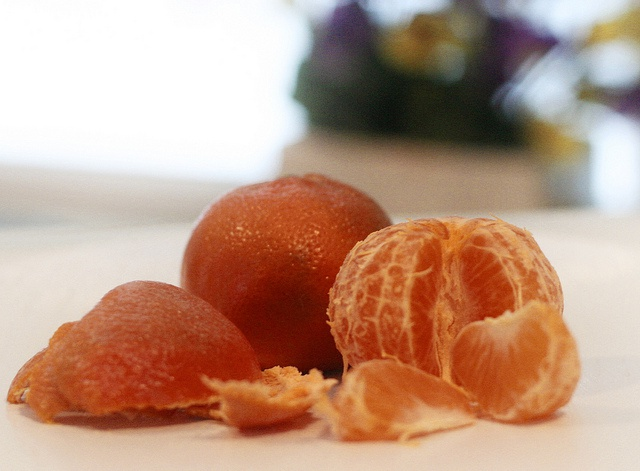Describe the objects in this image and their specific colors. I can see orange in white, red, tan, and brown tones, orange in white, brown, salmon, and tan tones, and orange in white, maroon, brown, and salmon tones in this image. 